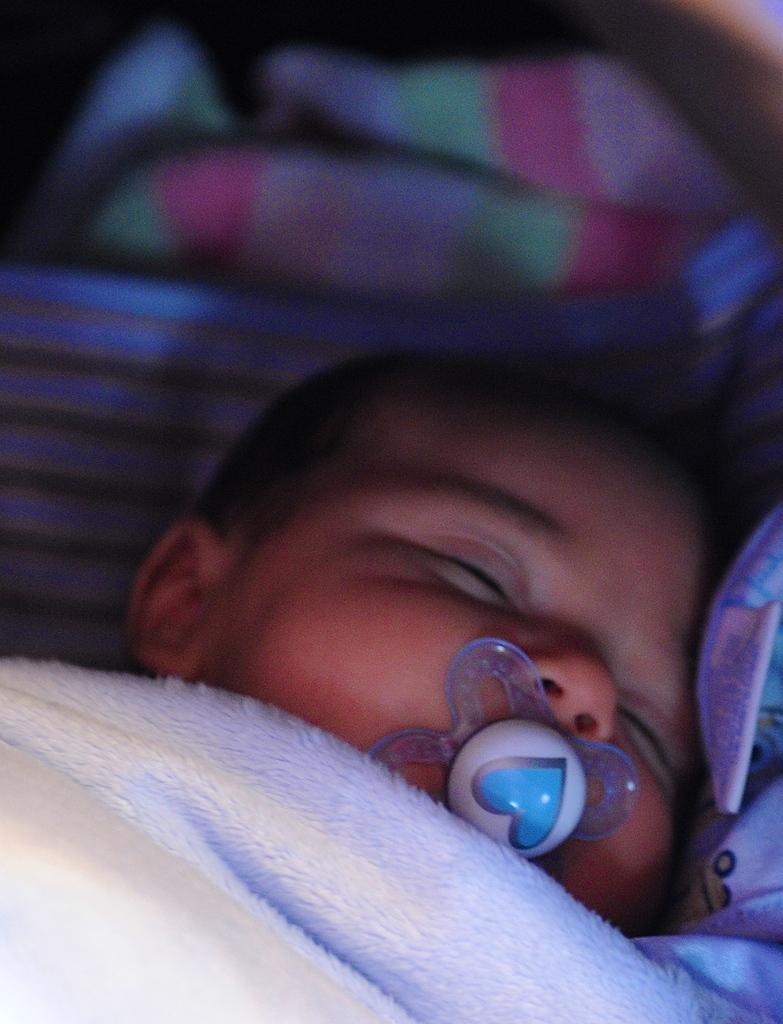Please provide a concise description of this image. In this picture there is a baby who is sleeping on the bed. At the bottom there is a white color blanket. At the top I can see the blur image. 